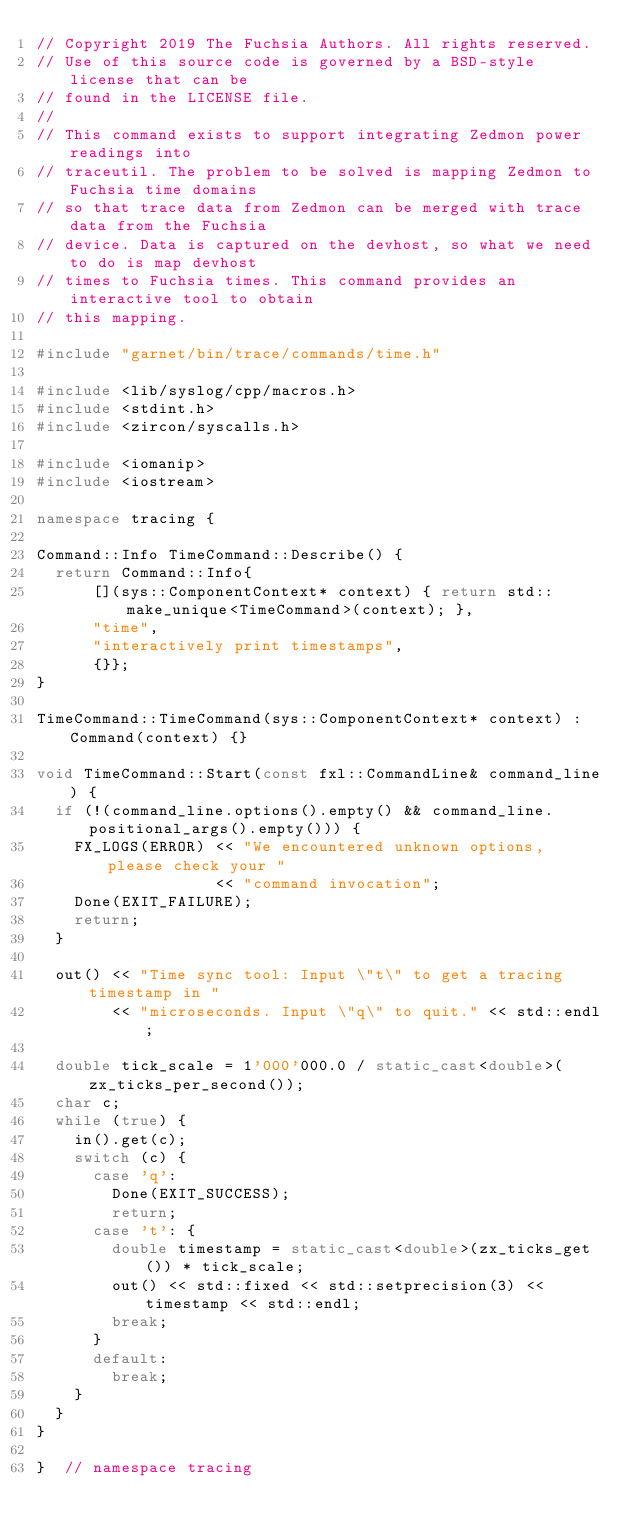Convert code to text. <code><loc_0><loc_0><loc_500><loc_500><_C++_>// Copyright 2019 The Fuchsia Authors. All rights reserved.
// Use of this source code is governed by a BSD-style license that can be
// found in the LICENSE file.
//
// This command exists to support integrating Zedmon power readings into
// traceutil. The problem to be solved is mapping Zedmon to Fuchsia time domains
// so that trace data from Zedmon can be merged with trace data from the Fuchsia
// device. Data is captured on the devhost, so what we need to do is map devhost
// times to Fuchsia times. This command provides an interactive tool to obtain
// this mapping.

#include "garnet/bin/trace/commands/time.h"

#include <lib/syslog/cpp/macros.h>
#include <stdint.h>
#include <zircon/syscalls.h>

#include <iomanip>
#include <iostream>

namespace tracing {

Command::Info TimeCommand::Describe() {
  return Command::Info{
      [](sys::ComponentContext* context) { return std::make_unique<TimeCommand>(context); },
      "time",
      "interactively print timestamps",
      {}};
}

TimeCommand::TimeCommand(sys::ComponentContext* context) : Command(context) {}

void TimeCommand::Start(const fxl::CommandLine& command_line) {
  if (!(command_line.options().empty() && command_line.positional_args().empty())) {
    FX_LOGS(ERROR) << "We encountered unknown options, please check your "
                   << "command invocation";
    Done(EXIT_FAILURE);
    return;
  }

  out() << "Time sync tool: Input \"t\" to get a tracing timestamp in "
        << "microseconds. Input \"q\" to quit." << std::endl;

  double tick_scale = 1'000'000.0 / static_cast<double>(zx_ticks_per_second());
  char c;
  while (true) {
    in().get(c);
    switch (c) {
      case 'q':
        Done(EXIT_SUCCESS);
        return;
      case 't': {
        double timestamp = static_cast<double>(zx_ticks_get()) * tick_scale;
        out() << std::fixed << std::setprecision(3) << timestamp << std::endl;
        break;
      }
      default:
        break;
    }
  }
}

}  // namespace tracing
</code> 